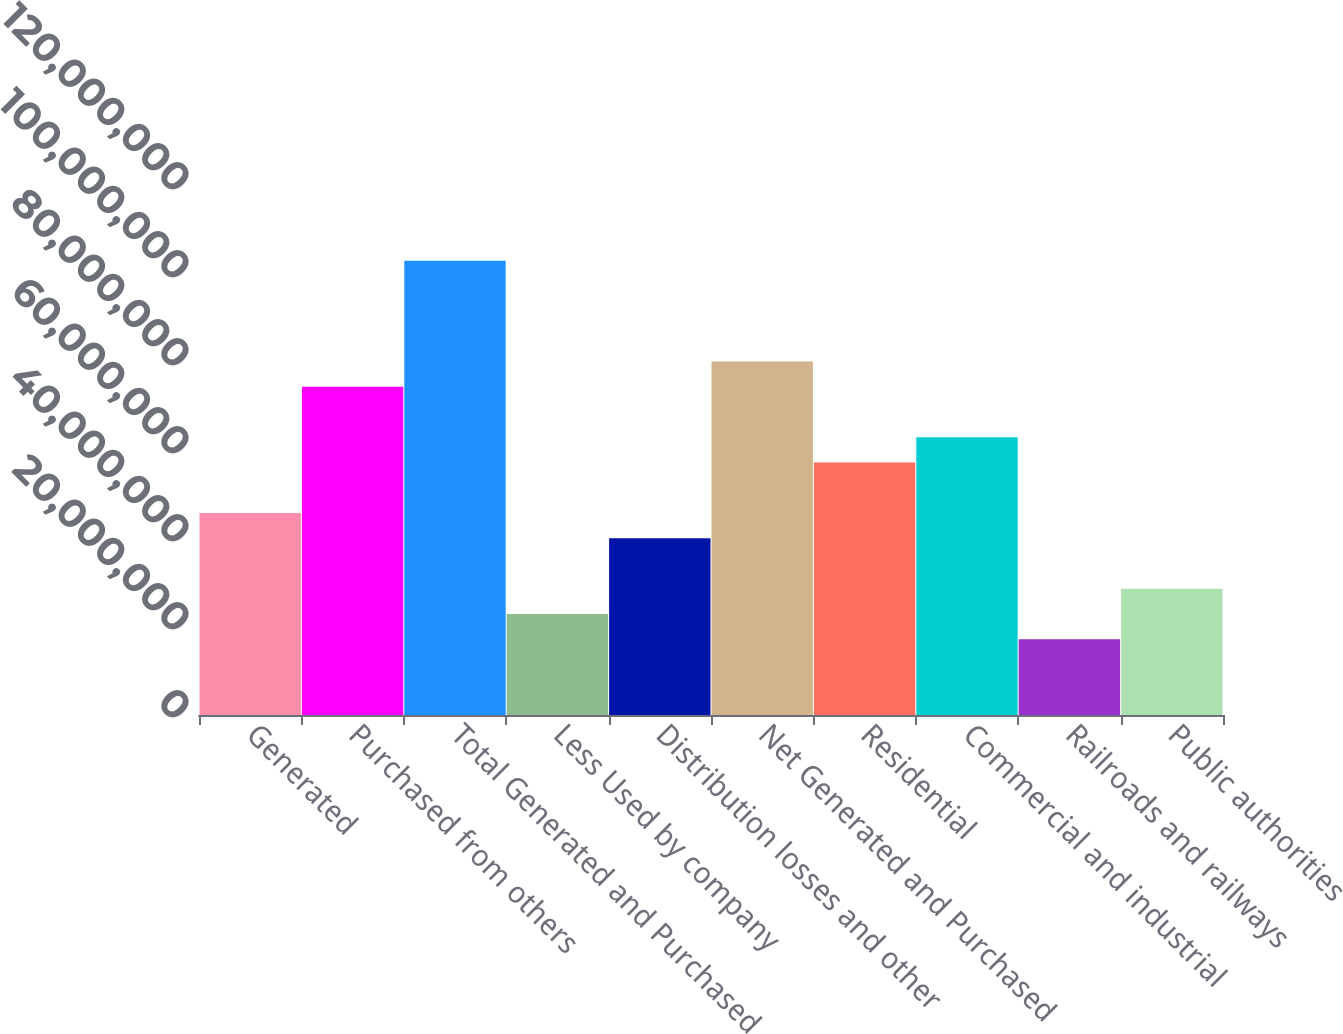<chart> <loc_0><loc_0><loc_500><loc_500><bar_chart><fcel>Generated<fcel>Purchased from others<fcel>Total Generated and Purchased<fcel>Less Used by company<fcel>Distribution losses and other<fcel>Net Generated and Purchased<fcel>Residential<fcel>Commercial and industrial<fcel>Railroads and railways<fcel>Public authorities<nl><fcel>4.58961e+07<fcel>7.45811e+07<fcel>1.03266e+08<fcel>2.2948e+07<fcel>4.01591e+07<fcel>8.03181e+07<fcel>5.73701e+07<fcel>6.31071e+07<fcel>1.7211e+07<fcel>2.8685e+07<nl></chart> 